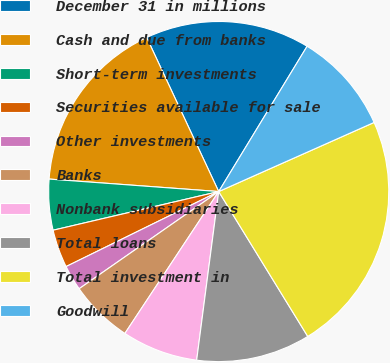Convert chart. <chart><loc_0><loc_0><loc_500><loc_500><pie_chart><fcel>December 31 in millions<fcel>Cash and due from banks<fcel>Short-term investments<fcel>Securities available for sale<fcel>Other investments<fcel>Banks<fcel>Nonbank subsidiaries<fcel>Total loans<fcel>Total investment in<fcel>Goodwill<nl><fcel>15.66%<fcel>16.87%<fcel>4.82%<fcel>3.62%<fcel>2.41%<fcel>6.02%<fcel>7.23%<fcel>10.84%<fcel>22.89%<fcel>9.64%<nl></chart> 